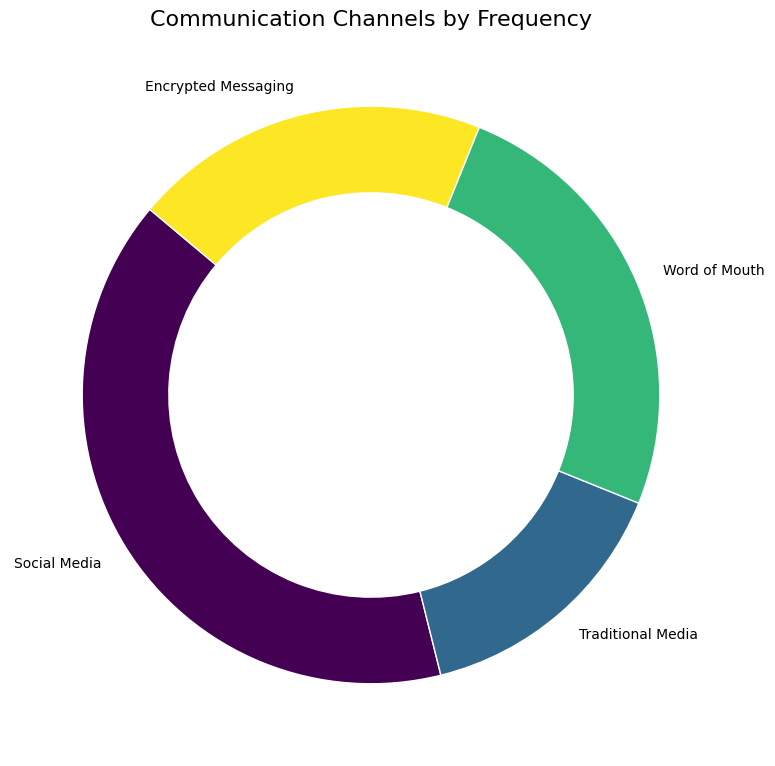what percentage of communication channels does social media account for? The pie chart shows the percentage next to each segment. For social media, the segment shows 40%, representing its proportion of the total communication channels.
Answer: 40% Which communication channel is used the least? By comparing the size and percentages of the segments, Traditional Media has the smallest segment with 15%, indicating it is used the least.
Answer: Traditional Media How much greater is the usage of Social Media compared to Word of Mouth? The percentage for Social Media is 40%, and for Word of Mouth, it is 25%. The difference is 40% - 25%, which equals 15%.
Answer: 15% If Traditional Media and Encrypted Messaging were combined, what would their total percentage be? The percentage for Traditional Media is 15% and for Encrypted Messaging is 20%. Combined, they would account for 15% + 20% = 35%.
Answer: 35% How do the usage percentages of Word of Mouth and Encrypted Messaging compare to each other? The pie chart shows that Word of Mouth is 25% and Encrypted Messaging is 20%. Word of Mouth is 5% greater than Encrypted Messaging.
Answer: Word of Mouth is 5% greater What proportion of the channels fall under non-digital mediums (Traditional Media and Word of Mouth)? Traditional Media accounts for 15% and Word of Mouth for 25%. Summing these gives 15% + 25% = 40%.
Answer: 40% What is the combined percentage of digital communication channels (Social Media and Encrypted Messaging)? Social Media accounts for 40% and Encrypted Messaging 20%. Their combined percentage is 40% + 20% = 60%.
Answer: 60% Which segment of the ring chart is the largest? By observing the sizes of the segments and the percentages displayed, Social Media with 40% is the largest segment.
Answer: Social Media If the usage of Encrypted Messaging doubled, what would its new percentage be, assuming the total remains 100%? If Encrypted Messaging doubled, it would be 20% * 2 = 40%. Adjusting this in the total of 100%, new distribution can't be directly calculated without altering the percentage of other channels.
Answer: Needs recalculation based on total Given that 100 locals participate, how many use Traditional Media? Traditional Media represents 15%. Therefore, 15% of 100 individuals would be 15 locals.
Answer: 15 